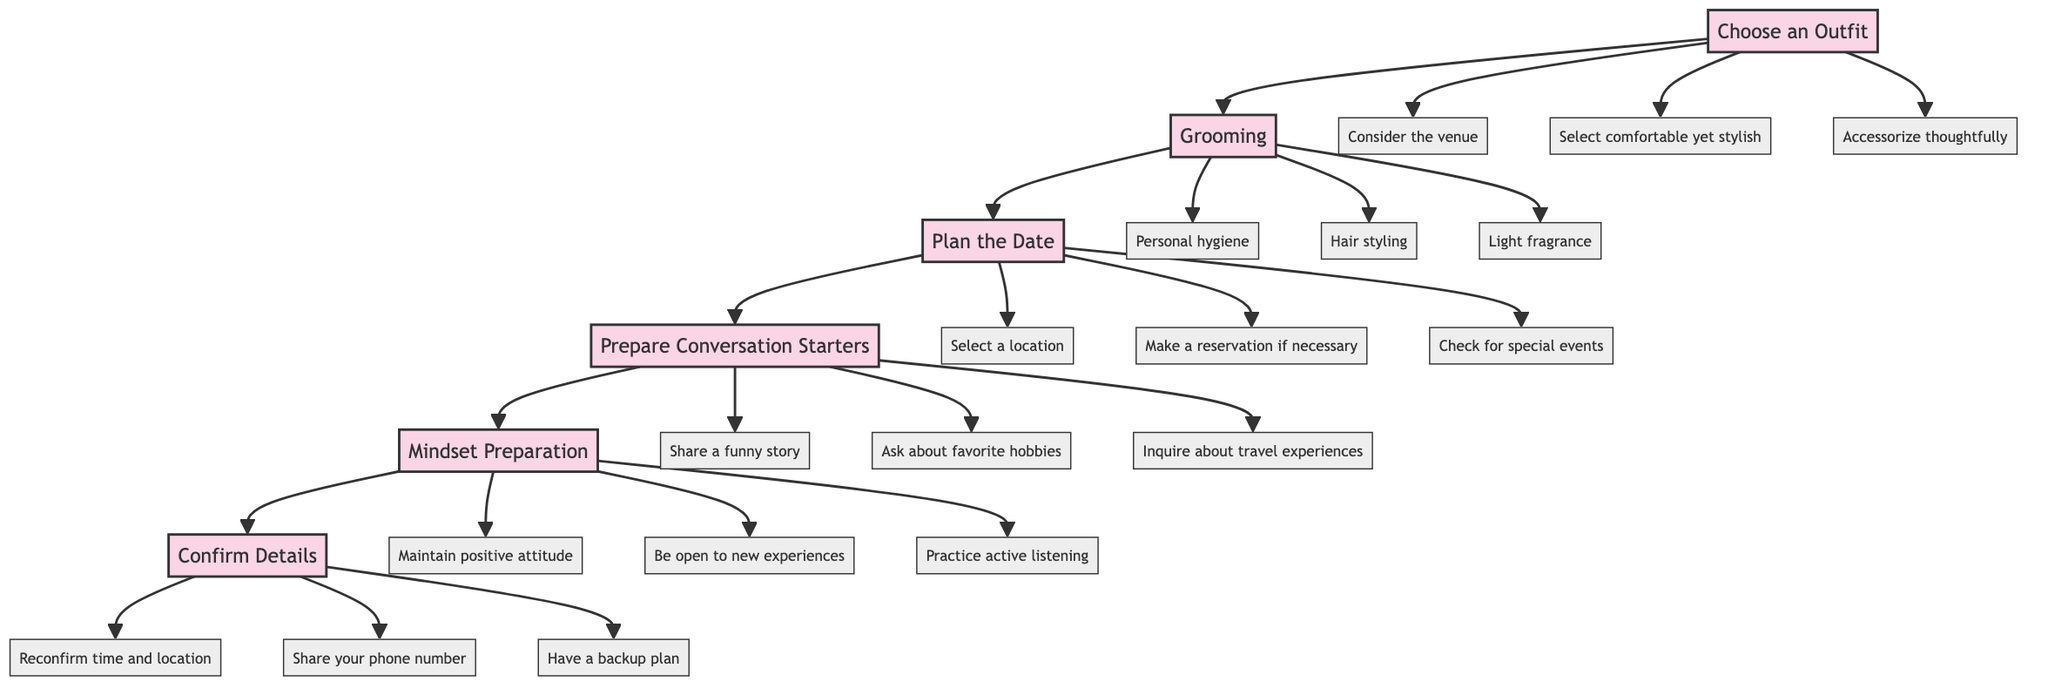What is the first step in the flow chart? The flow chart starts with the "Choose an Outfit" step, which is the topmost node in the diagram.
Answer: Choose an Outfit How many detail points are listed under "Grooming"? The "Grooming" step has three detail points connected to it: "Personal hygiene", "Hair styling", and "Light fragrance". Therefore, there are a total of three detail points.
Answer: 3 What step comes after "Plan the Date"? In the flow chart, "Prepare Conversation Starters" directly follows "Plan the Date" as indicated by the directional flow from one node to the next.
Answer: Prepare Conversation Starters What is the last step in the flow chart? The last step in the flow chart is "Confirm Details", which is the final node in the sequence leading toward the end of the diagram.
Answer: Confirm Details List one detail from the "Prepare Conversation Starters" step. The "Prepare Conversation Starters" step has multiple details, one of which is "Share a funny story", which is one of the options listed under that step.
Answer: Share a funny story How many total nodes are present in the flow chart? The flow chart consists of six main steps (nodes) and their corresponding detail nodes. Since there are six steps each with three details, there are a total of 6+18=24 nodes.
Answer: 24 What is the relationship between "Choose an Outfit" and "Grooming"? "Choose an Outfit" and "Grooming" are steps in the chart that are sequential; they both lead into the subsequent planning and preparation steps for a first date as outlined in the flow, but they are not directly connected to each other in this instance.
Answer: Sequential Name one mindset preparation detail. One detail listed under "Mindset Preparation" is "Maintain a positive attitude," which reflects the importance of maintaining a good mindset prior to the date.
Answer: Maintain a positive attitude What do you need to confirm before the date? Before the date, it is necessary to "Reconfirm time and location" as outlined in the "Confirm Details" step. This ensures everything is set and clear for the date.
Answer: Reconfirm time and location 